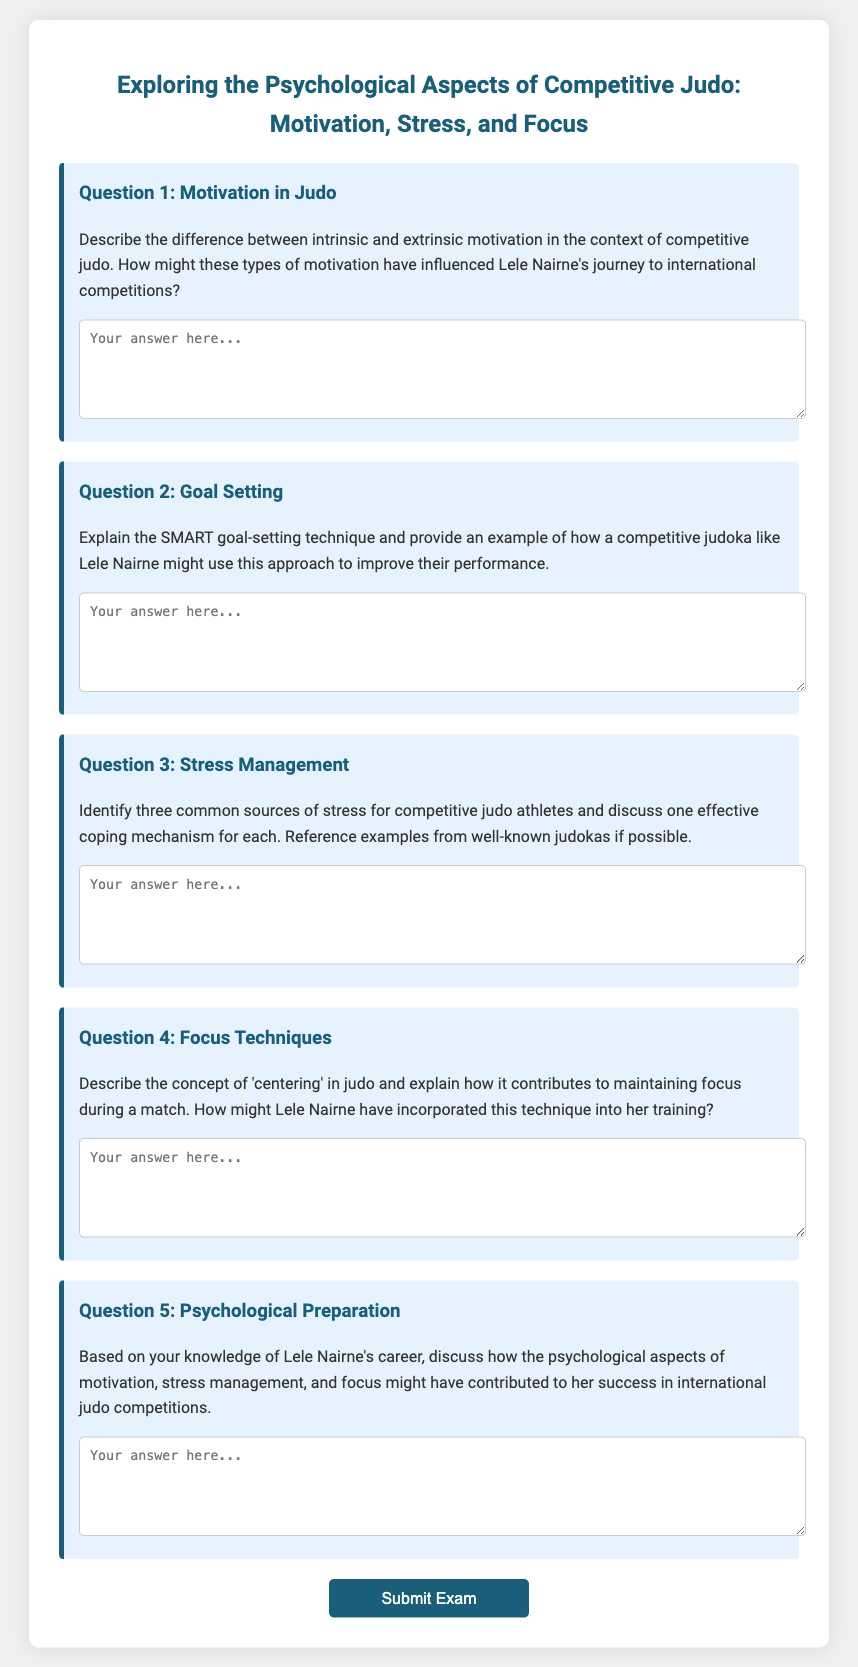What is the title of the document? The title of the document is prominently displayed in the heading of the exam.
Answer: Exploring the Psychological Aspects of Competitive Judo: Motivation, Stress, and Focus How many questions are included in the exam? The number of questions is indicated by the individual sections within the exam container.
Answer: 5 What is the focus of Question 3? The focus of Question 3 is to identify sources of stress and coping mechanisms related to judo.
Answer: Stress Management What psychological aspect does Question 5 discuss? Question 5 discusses the psychological aspects that may have contributed to Lele Nairne's success.
Answer: Psychological Preparation What type of goal-setting technique is mentioned in Question 2? The type of goal-setting technique mentioned in Question 2 is referred to by its acronym.
Answer: SMART 